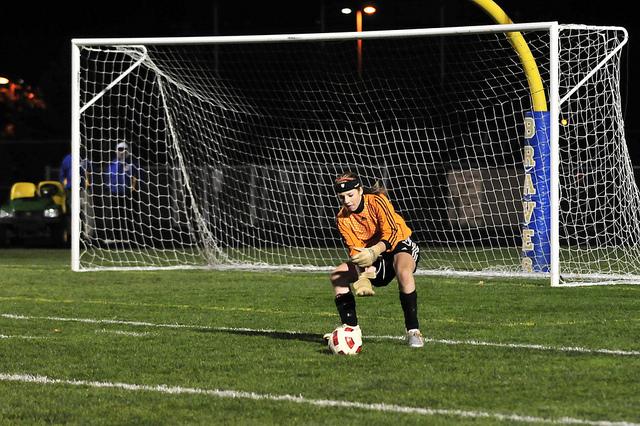What is the person trying to grab?
Be succinct. Ball. What position is this person playing?
Write a very short answer. Goalie. What does it say behind the goal?
Give a very brief answer. Braves. 